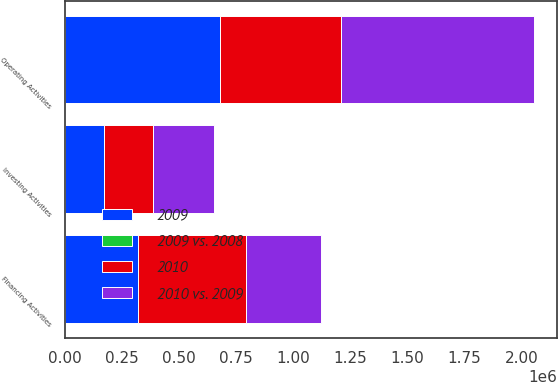Convert chart. <chart><loc_0><loc_0><loc_500><loc_500><stacked_bar_chart><ecel><fcel>Operating Activities<fcel>Investing Activities<fcel>Financing Activities<nl><fcel>2009<fcel>678663<fcel>172348<fcel>320569<nl><fcel>2010 vs. 2009<fcel>845298<fcel>264420<fcel>330383<nl><fcel>2010<fcel>530309<fcel>214334<fcel>472573<nl><fcel>2009 vs. 2008<fcel>20<fcel>35<fcel>3<nl></chart> 